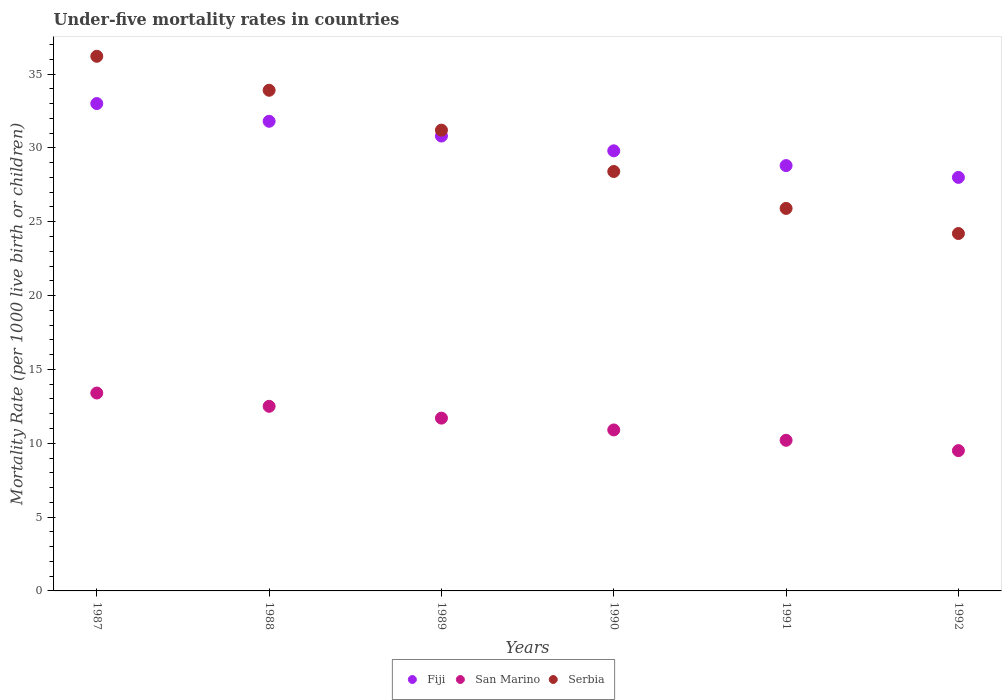Is the number of dotlines equal to the number of legend labels?
Keep it short and to the point. Yes. Across all years, what is the maximum under-five mortality rate in Serbia?
Offer a terse response. 36.2. Across all years, what is the minimum under-five mortality rate in San Marino?
Offer a very short reply. 9.5. In which year was the under-five mortality rate in Fiji maximum?
Make the answer very short. 1987. What is the total under-five mortality rate in San Marino in the graph?
Your response must be concise. 68.2. What is the difference between the under-five mortality rate in Fiji in 1987 and that in 1990?
Make the answer very short. 3.2. What is the difference between the under-five mortality rate in San Marino in 1989 and the under-five mortality rate in Fiji in 1990?
Provide a succinct answer. -18.1. What is the average under-five mortality rate in Serbia per year?
Your response must be concise. 29.97. In the year 1991, what is the difference between the under-five mortality rate in San Marino and under-five mortality rate in Serbia?
Your answer should be compact. -15.7. What is the ratio of the under-five mortality rate in San Marino in 1987 to that in 1991?
Your answer should be compact. 1.31. Is the under-five mortality rate in San Marino in 1990 less than that in 1992?
Offer a very short reply. No. Is the difference between the under-five mortality rate in San Marino in 1990 and 1992 greater than the difference between the under-five mortality rate in Serbia in 1990 and 1992?
Keep it short and to the point. No. What is the difference between the highest and the second highest under-five mortality rate in Fiji?
Provide a succinct answer. 1.2. What is the difference between the highest and the lowest under-five mortality rate in San Marino?
Offer a very short reply. 3.9. In how many years, is the under-five mortality rate in San Marino greater than the average under-five mortality rate in San Marino taken over all years?
Give a very brief answer. 3. Is the sum of the under-five mortality rate in San Marino in 1989 and 1990 greater than the maximum under-five mortality rate in Fiji across all years?
Your response must be concise. No. Does the under-five mortality rate in Serbia monotonically increase over the years?
Your response must be concise. No. Is the under-five mortality rate in San Marino strictly greater than the under-five mortality rate in Serbia over the years?
Ensure brevity in your answer.  No. Is the under-five mortality rate in San Marino strictly less than the under-five mortality rate in Serbia over the years?
Ensure brevity in your answer.  Yes. How many years are there in the graph?
Your response must be concise. 6. What is the difference between two consecutive major ticks on the Y-axis?
Your response must be concise. 5. Are the values on the major ticks of Y-axis written in scientific E-notation?
Provide a short and direct response. No. Does the graph contain any zero values?
Provide a succinct answer. No. How many legend labels are there?
Ensure brevity in your answer.  3. How are the legend labels stacked?
Your answer should be very brief. Horizontal. What is the title of the graph?
Ensure brevity in your answer.  Under-five mortality rates in countries. Does "Portugal" appear as one of the legend labels in the graph?
Give a very brief answer. No. What is the label or title of the Y-axis?
Give a very brief answer. Mortality Rate (per 1000 live birth or children). What is the Mortality Rate (per 1000 live birth or children) of Serbia in 1987?
Offer a very short reply. 36.2. What is the Mortality Rate (per 1000 live birth or children) of Fiji in 1988?
Keep it short and to the point. 31.8. What is the Mortality Rate (per 1000 live birth or children) in San Marino in 1988?
Offer a terse response. 12.5. What is the Mortality Rate (per 1000 live birth or children) of Serbia in 1988?
Give a very brief answer. 33.9. What is the Mortality Rate (per 1000 live birth or children) in Fiji in 1989?
Provide a short and direct response. 30.8. What is the Mortality Rate (per 1000 live birth or children) of San Marino in 1989?
Ensure brevity in your answer.  11.7. What is the Mortality Rate (per 1000 live birth or children) in Serbia in 1989?
Make the answer very short. 31.2. What is the Mortality Rate (per 1000 live birth or children) of Fiji in 1990?
Your response must be concise. 29.8. What is the Mortality Rate (per 1000 live birth or children) of Serbia in 1990?
Provide a succinct answer. 28.4. What is the Mortality Rate (per 1000 live birth or children) in Fiji in 1991?
Your answer should be compact. 28.8. What is the Mortality Rate (per 1000 live birth or children) of Serbia in 1991?
Offer a terse response. 25.9. What is the Mortality Rate (per 1000 live birth or children) in Serbia in 1992?
Your response must be concise. 24.2. Across all years, what is the maximum Mortality Rate (per 1000 live birth or children) in San Marino?
Provide a succinct answer. 13.4. Across all years, what is the maximum Mortality Rate (per 1000 live birth or children) in Serbia?
Give a very brief answer. 36.2. Across all years, what is the minimum Mortality Rate (per 1000 live birth or children) in Fiji?
Offer a terse response. 28. Across all years, what is the minimum Mortality Rate (per 1000 live birth or children) of San Marino?
Offer a terse response. 9.5. Across all years, what is the minimum Mortality Rate (per 1000 live birth or children) of Serbia?
Offer a very short reply. 24.2. What is the total Mortality Rate (per 1000 live birth or children) in Fiji in the graph?
Offer a terse response. 182.2. What is the total Mortality Rate (per 1000 live birth or children) of San Marino in the graph?
Give a very brief answer. 68.2. What is the total Mortality Rate (per 1000 live birth or children) of Serbia in the graph?
Give a very brief answer. 179.8. What is the difference between the Mortality Rate (per 1000 live birth or children) of Serbia in 1987 and that in 1988?
Make the answer very short. 2.3. What is the difference between the Mortality Rate (per 1000 live birth or children) of Fiji in 1987 and that in 1989?
Your answer should be very brief. 2.2. What is the difference between the Mortality Rate (per 1000 live birth or children) of San Marino in 1987 and that in 1989?
Provide a succinct answer. 1.7. What is the difference between the Mortality Rate (per 1000 live birth or children) of Serbia in 1987 and that in 1989?
Your answer should be very brief. 5. What is the difference between the Mortality Rate (per 1000 live birth or children) of Fiji in 1987 and that in 1991?
Ensure brevity in your answer.  4.2. What is the difference between the Mortality Rate (per 1000 live birth or children) of San Marino in 1987 and that in 1991?
Ensure brevity in your answer.  3.2. What is the difference between the Mortality Rate (per 1000 live birth or children) in Serbia in 1987 and that in 1991?
Give a very brief answer. 10.3. What is the difference between the Mortality Rate (per 1000 live birth or children) of Fiji in 1987 and that in 1992?
Offer a terse response. 5. What is the difference between the Mortality Rate (per 1000 live birth or children) of San Marino in 1988 and that in 1989?
Offer a very short reply. 0.8. What is the difference between the Mortality Rate (per 1000 live birth or children) in Serbia in 1988 and that in 1989?
Give a very brief answer. 2.7. What is the difference between the Mortality Rate (per 1000 live birth or children) in Serbia in 1988 and that in 1990?
Your response must be concise. 5.5. What is the difference between the Mortality Rate (per 1000 live birth or children) of San Marino in 1988 and that in 1991?
Make the answer very short. 2.3. What is the difference between the Mortality Rate (per 1000 live birth or children) of Fiji in 1988 and that in 1992?
Offer a very short reply. 3.8. What is the difference between the Mortality Rate (per 1000 live birth or children) of Serbia in 1989 and that in 1991?
Provide a succinct answer. 5.3. What is the difference between the Mortality Rate (per 1000 live birth or children) in Fiji in 1989 and that in 1992?
Your answer should be compact. 2.8. What is the difference between the Mortality Rate (per 1000 live birth or children) of San Marino in 1989 and that in 1992?
Your answer should be very brief. 2.2. What is the difference between the Mortality Rate (per 1000 live birth or children) of Serbia in 1989 and that in 1992?
Make the answer very short. 7. What is the difference between the Mortality Rate (per 1000 live birth or children) in Fiji in 1990 and that in 1991?
Offer a terse response. 1. What is the difference between the Mortality Rate (per 1000 live birth or children) in San Marino in 1990 and that in 1992?
Your response must be concise. 1.4. What is the difference between the Mortality Rate (per 1000 live birth or children) of Serbia in 1990 and that in 1992?
Your answer should be very brief. 4.2. What is the difference between the Mortality Rate (per 1000 live birth or children) in Serbia in 1991 and that in 1992?
Ensure brevity in your answer.  1.7. What is the difference between the Mortality Rate (per 1000 live birth or children) in San Marino in 1987 and the Mortality Rate (per 1000 live birth or children) in Serbia in 1988?
Offer a very short reply. -20.5. What is the difference between the Mortality Rate (per 1000 live birth or children) in Fiji in 1987 and the Mortality Rate (per 1000 live birth or children) in San Marino in 1989?
Your answer should be compact. 21.3. What is the difference between the Mortality Rate (per 1000 live birth or children) of San Marino in 1987 and the Mortality Rate (per 1000 live birth or children) of Serbia in 1989?
Your response must be concise. -17.8. What is the difference between the Mortality Rate (per 1000 live birth or children) in Fiji in 1987 and the Mortality Rate (per 1000 live birth or children) in San Marino in 1990?
Keep it short and to the point. 22.1. What is the difference between the Mortality Rate (per 1000 live birth or children) of Fiji in 1987 and the Mortality Rate (per 1000 live birth or children) of Serbia in 1990?
Keep it short and to the point. 4.6. What is the difference between the Mortality Rate (per 1000 live birth or children) in Fiji in 1987 and the Mortality Rate (per 1000 live birth or children) in San Marino in 1991?
Your answer should be compact. 22.8. What is the difference between the Mortality Rate (per 1000 live birth or children) in Fiji in 1987 and the Mortality Rate (per 1000 live birth or children) in Serbia in 1991?
Offer a terse response. 7.1. What is the difference between the Mortality Rate (per 1000 live birth or children) of San Marino in 1987 and the Mortality Rate (per 1000 live birth or children) of Serbia in 1991?
Your answer should be very brief. -12.5. What is the difference between the Mortality Rate (per 1000 live birth or children) of Fiji in 1987 and the Mortality Rate (per 1000 live birth or children) of Serbia in 1992?
Keep it short and to the point. 8.8. What is the difference between the Mortality Rate (per 1000 live birth or children) of Fiji in 1988 and the Mortality Rate (per 1000 live birth or children) of San Marino in 1989?
Provide a short and direct response. 20.1. What is the difference between the Mortality Rate (per 1000 live birth or children) of San Marino in 1988 and the Mortality Rate (per 1000 live birth or children) of Serbia in 1989?
Provide a short and direct response. -18.7. What is the difference between the Mortality Rate (per 1000 live birth or children) in Fiji in 1988 and the Mortality Rate (per 1000 live birth or children) in San Marino in 1990?
Your answer should be compact. 20.9. What is the difference between the Mortality Rate (per 1000 live birth or children) of San Marino in 1988 and the Mortality Rate (per 1000 live birth or children) of Serbia in 1990?
Keep it short and to the point. -15.9. What is the difference between the Mortality Rate (per 1000 live birth or children) in Fiji in 1988 and the Mortality Rate (per 1000 live birth or children) in San Marino in 1991?
Your answer should be compact. 21.6. What is the difference between the Mortality Rate (per 1000 live birth or children) of Fiji in 1988 and the Mortality Rate (per 1000 live birth or children) of Serbia in 1991?
Your answer should be very brief. 5.9. What is the difference between the Mortality Rate (per 1000 live birth or children) of Fiji in 1988 and the Mortality Rate (per 1000 live birth or children) of San Marino in 1992?
Your response must be concise. 22.3. What is the difference between the Mortality Rate (per 1000 live birth or children) of San Marino in 1988 and the Mortality Rate (per 1000 live birth or children) of Serbia in 1992?
Offer a terse response. -11.7. What is the difference between the Mortality Rate (per 1000 live birth or children) of Fiji in 1989 and the Mortality Rate (per 1000 live birth or children) of San Marino in 1990?
Offer a terse response. 19.9. What is the difference between the Mortality Rate (per 1000 live birth or children) of Fiji in 1989 and the Mortality Rate (per 1000 live birth or children) of Serbia in 1990?
Your answer should be very brief. 2.4. What is the difference between the Mortality Rate (per 1000 live birth or children) in San Marino in 1989 and the Mortality Rate (per 1000 live birth or children) in Serbia in 1990?
Offer a very short reply. -16.7. What is the difference between the Mortality Rate (per 1000 live birth or children) of Fiji in 1989 and the Mortality Rate (per 1000 live birth or children) of San Marino in 1991?
Provide a short and direct response. 20.6. What is the difference between the Mortality Rate (per 1000 live birth or children) in San Marino in 1989 and the Mortality Rate (per 1000 live birth or children) in Serbia in 1991?
Make the answer very short. -14.2. What is the difference between the Mortality Rate (per 1000 live birth or children) of Fiji in 1989 and the Mortality Rate (per 1000 live birth or children) of San Marino in 1992?
Your answer should be compact. 21.3. What is the difference between the Mortality Rate (per 1000 live birth or children) in Fiji in 1989 and the Mortality Rate (per 1000 live birth or children) in Serbia in 1992?
Keep it short and to the point. 6.6. What is the difference between the Mortality Rate (per 1000 live birth or children) of Fiji in 1990 and the Mortality Rate (per 1000 live birth or children) of San Marino in 1991?
Offer a terse response. 19.6. What is the difference between the Mortality Rate (per 1000 live birth or children) of San Marino in 1990 and the Mortality Rate (per 1000 live birth or children) of Serbia in 1991?
Your answer should be compact. -15. What is the difference between the Mortality Rate (per 1000 live birth or children) in Fiji in 1990 and the Mortality Rate (per 1000 live birth or children) in San Marino in 1992?
Keep it short and to the point. 20.3. What is the difference between the Mortality Rate (per 1000 live birth or children) of Fiji in 1990 and the Mortality Rate (per 1000 live birth or children) of Serbia in 1992?
Provide a succinct answer. 5.6. What is the difference between the Mortality Rate (per 1000 live birth or children) of San Marino in 1990 and the Mortality Rate (per 1000 live birth or children) of Serbia in 1992?
Give a very brief answer. -13.3. What is the difference between the Mortality Rate (per 1000 live birth or children) in Fiji in 1991 and the Mortality Rate (per 1000 live birth or children) in San Marino in 1992?
Make the answer very short. 19.3. What is the difference between the Mortality Rate (per 1000 live birth or children) of Fiji in 1991 and the Mortality Rate (per 1000 live birth or children) of Serbia in 1992?
Your answer should be compact. 4.6. What is the difference between the Mortality Rate (per 1000 live birth or children) in San Marino in 1991 and the Mortality Rate (per 1000 live birth or children) in Serbia in 1992?
Make the answer very short. -14. What is the average Mortality Rate (per 1000 live birth or children) of Fiji per year?
Offer a very short reply. 30.37. What is the average Mortality Rate (per 1000 live birth or children) of San Marino per year?
Offer a very short reply. 11.37. What is the average Mortality Rate (per 1000 live birth or children) of Serbia per year?
Provide a succinct answer. 29.97. In the year 1987, what is the difference between the Mortality Rate (per 1000 live birth or children) of Fiji and Mortality Rate (per 1000 live birth or children) of San Marino?
Your answer should be very brief. 19.6. In the year 1987, what is the difference between the Mortality Rate (per 1000 live birth or children) in San Marino and Mortality Rate (per 1000 live birth or children) in Serbia?
Make the answer very short. -22.8. In the year 1988, what is the difference between the Mortality Rate (per 1000 live birth or children) of Fiji and Mortality Rate (per 1000 live birth or children) of San Marino?
Offer a very short reply. 19.3. In the year 1988, what is the difference between the Mortality Rate (per 1000 live birth or children) in San Marino and Mortality Rate (per 1000 live birth or children) in Serbia?
Offer a terse response. -21.4. In the year 1989, what is the difference between the Mortality Rate (per 1000 live birth or children) in Fiji and Mortality Rate (per 1000 live birth or children) in San Marino?
Provide a short and direct response. 19.1. In the year 1989, what is the difference between the Mortality Rate (per 1000 live birth or children) of Fiji and Mortality Rate (per 1000 live birth or children) of Serbia?
Ensure brevity in your answer.  -0.4. In the year 1989, what is the difference between the Mortality Rate (per 1000 live birth or children) of San Marino and Mortality Rate (per 1000 live birth or children) of Serbia?
Your answer should be very brief. -19.5. In the year 1990, what is the difference between the Mortality Rate (per 1000 live birth or children) in Fiji and Mortality Rate (per 1000 live birth or children) in Serbia?
Give a very brief answer. 1.4. In the year 1990, what is the difference between the Mortality Rate (per 1000 live birth or children) in San Marino and Mortality Rate (per 1000 live birth or children) in Serbia?
Give a very brief answer. -17.5. In the year 1991, what is the difference between the Mortality Rate (per 1000 live birth or children) of San Marino and Mortality Rate (per 1000 live birth or children) of Serbia?
Offer a very short reply. -15.7. In the year 1992, what is the difference between the Mortality Rate (per 1000 live birth or children) in San Marino and Mortality Rate (per 1000 live birth or children) in Serbia?
Give a very brief answer. -14.7. What is the ratio of the Mortality Rate (per 1000 live birth or children) of Fiji in 1987 to that in 1988?
Offer a terse response. 1.04. What is the ratio of the Mortality Rate (per 1000 live birth or children) of San Marino in 1987 to that in 1988?
Give a very brief answer. 1.07. What is the ratio of the Mortality Rate (per 1000 live birth or children) in Serbia in 1987 to that in 1988?
Make the answer very short. 1.07. What is the ratio of the Mortality Rate (per 1000 live birth or children) of Fiji in 1987 to that in 1989?
Make the answer very short. 1.07. What is the ratio of the Mortality Rate (per 1000 live birth or children) of San Marino in 1987 to that in 1989?
Your answer should be compact. 1.15. What is the ratio of the Mortality Rate (per 1000 live birth or children) of Serbia in 1987 to that in 1989?
Offer a terse response. 1.16. What is the ratio of the Mortality Rate (per 1000 live birth or children) in Fiji in 1987 to that in 1990?
Offer a terse response. 1.11. What is the ratio of the Mortality Rate (per 1000 live birth or children) in San Marino in 1987 to that in 1990?
Your answer should be compact. 1.23. What is the ratio of the Mortality Rate (per 1000 live birth or children) in Serbia in 1987 to that in 1990?
Keep it short and to the point. 1.27. What is the ratio of the Mortality Rate (per 1000 live birth or children) of Fiji in 1987 to that in 1991?
Your answer should be compact. 1.15. What is the ratio of the Mortality Rate (per 1000 live birth or children) of San Marino in 1987 to that in 1991?
Ensure brevity in your answer.  1.31. What is the ratio of the Mortality Rate (per 1000 live birth or children) of Serbia in 1987 to that in 1991?
Your response must be concise. 1.4. What is the ratio of the Mortality Rate (per 1000 live birth or children) in Fiji in 1987 to that in 1992?
Offer a very short reply. 1.18. What is the ratio of the Mortality Rate (per 1000 live birth or children) in San Marino in 1987 to that in 1992?
Give a very brief answer. 1.41. What is the ratio of the Mortality Rate (per 1000 live birth or children) of Serbia in 1987 to that in 1992?
Your response must be concise. 1.5. What is the ratio of the Mortality Rate (per 1000 live birth or children) of Fiji in 1988 to that in 1989?
Your answer should be compact. 1.03. What is the ratio of the Mortality Rate (per 1000 live birth or children) in San Marino in 1988 to that in 1989?
Your answer should be very brief. 1.07. What is the ratio of the Mortality Rate (per 1000 live birth or children) in Serbia in 1988 to that in 1989?
Offer a very short reply. 1.09. What is the ratio of the Mortality Rate (per 1000 live birth or children) of Fiji in 1988 to that in 1990?
Provide a short and direct response. 1.07. What is the ratio of the Mortality Rate (per 1000 live birth or children) of San Marino in 1988 to that in 1990?
Provide a succinct answer. 1.15. What is the ratio of the Mortality Rate (per 1000 live birth or children) in Serbia in 1988 to that in 1990?
Provide a succinct answer. 1.19. What is the ratio of the Mortality Rate (per 1000 live birth or children) of Fiji in 1988 to that in 1991?
Provide a short and direct response. 1.1. What is the ratio of the Mortality Rate (per 1000 live birth or children) of San Marino in 1988 to that in 1991?
Make the answer very short. 1.23. What is the ratio of the Mortality Rate (per 1000 live birth or children) of Serbia in 1988 to that in 1991?
Make the answer very short. 1.31. What is the ratio of the Mortality Rate (per 1000 live birth or children) of Fiji in 1988 to that in 1992?
Give a very brief answer. 1.14. What is the ratio of the Mortality Rate (per 1000 live birth or children) of San Marino in 1988 to that in 1992?
Offer a terse response. 1.32. What is the ratio of the Mortality Rate (per 1000 live birth or children) in Serbia in 1988 to that in 1992?
Your response must be concise. 1.4. What is the ratio of the Mortality Rate (per 1000 live birth or children) in Fiji in 1989 to that in 1990?
Your response must be concise. 1.03. What is the ratio of the Mortality Rate (per 1000 live birth or children) of San Marino in 1989 to that in 1990?
Ensure brevity in your answer.  1.07. What is the ratio of the Mortality Rate (per 1000 live birth or children) of Serbia in 1989 to that in 1990?
Make the answer very short. 1.1. What is the ratio of the Mortality Rate (per 1000 live birth or children) of Fiji in 1989 to that in 1991?
Your answer should be very brief. 1.07. What is the ratio of the Mortality Rate (per 1000 live birth or children) in San Marino in 1989 to that in 1991?
Make the answer very short. 1.15. What is the ratio of the Mortality Rate (per 1000 live birth or children) of Serbia in 1989 to that in 1991?
Ensure brevity in your answer.  1.2. What is the ratio of the Mortality Rate (per 1000 live birth or children) of San Marino in 1989 to that in 1992?
Offer a very short reply. 1.23. What is the ratio of the Mortality Rate (per 1000 live birth or children) in Serbia in 1989 to that in 1992?
Provide a short and direct response. 1.29. What is the ratio of the Mortality Rate (per 1000 live birth or children) of Fiji in 1990 to that in 1991?
Make the answer very short. 1.03. What is the ratio of the Mortality Rate (per 1000 live birth or children) of San Marino in 1990 to that in 1991?
Offer a very short reply. 1.07. What is the ratio of the Mortality Rate (per 1000 live birth or children) in Serbia in 1990 to that in 1991?
Your answer should be compact. 1.1. What is the ratio of the Mortality Rate (per 1000 live birth or children) in Fiji in 1990 to that in 1992?
Your answer should be very brief. 1.06. What is the ratio of the Mortality Rate (per 1000 live birth or children) of San Marino in 1990 to that in 1992?
Give a very brief answer. 1.15. What is the ratio of the Mortality Rate (per 1000 live birth or children) of Serbia in 1990 to that in 1992?
Keep it short and to the point. 1.17. What is the ratio of the Mortality Rate (per 1000 live birth or children) of Fiji in 1991 to that in 1992?
Your answer should be compact. 1.03. What is the ratio of the Mortality Rate (per 1000 live birth or children) in San Marino in 1991 to that in 1992?
Your answer should be very brief. 1.07. What is the ratio of the Mortality Rate (per 1000 live birth or children) of Serbia in 1991 to that in 1992?
Offer a terse response. 1.07. What is the difference between the highest and the second highest Mortality Rate (per 1000 live birth or children) in Fiji?
Ensure brevity in your answer.  1.2. 